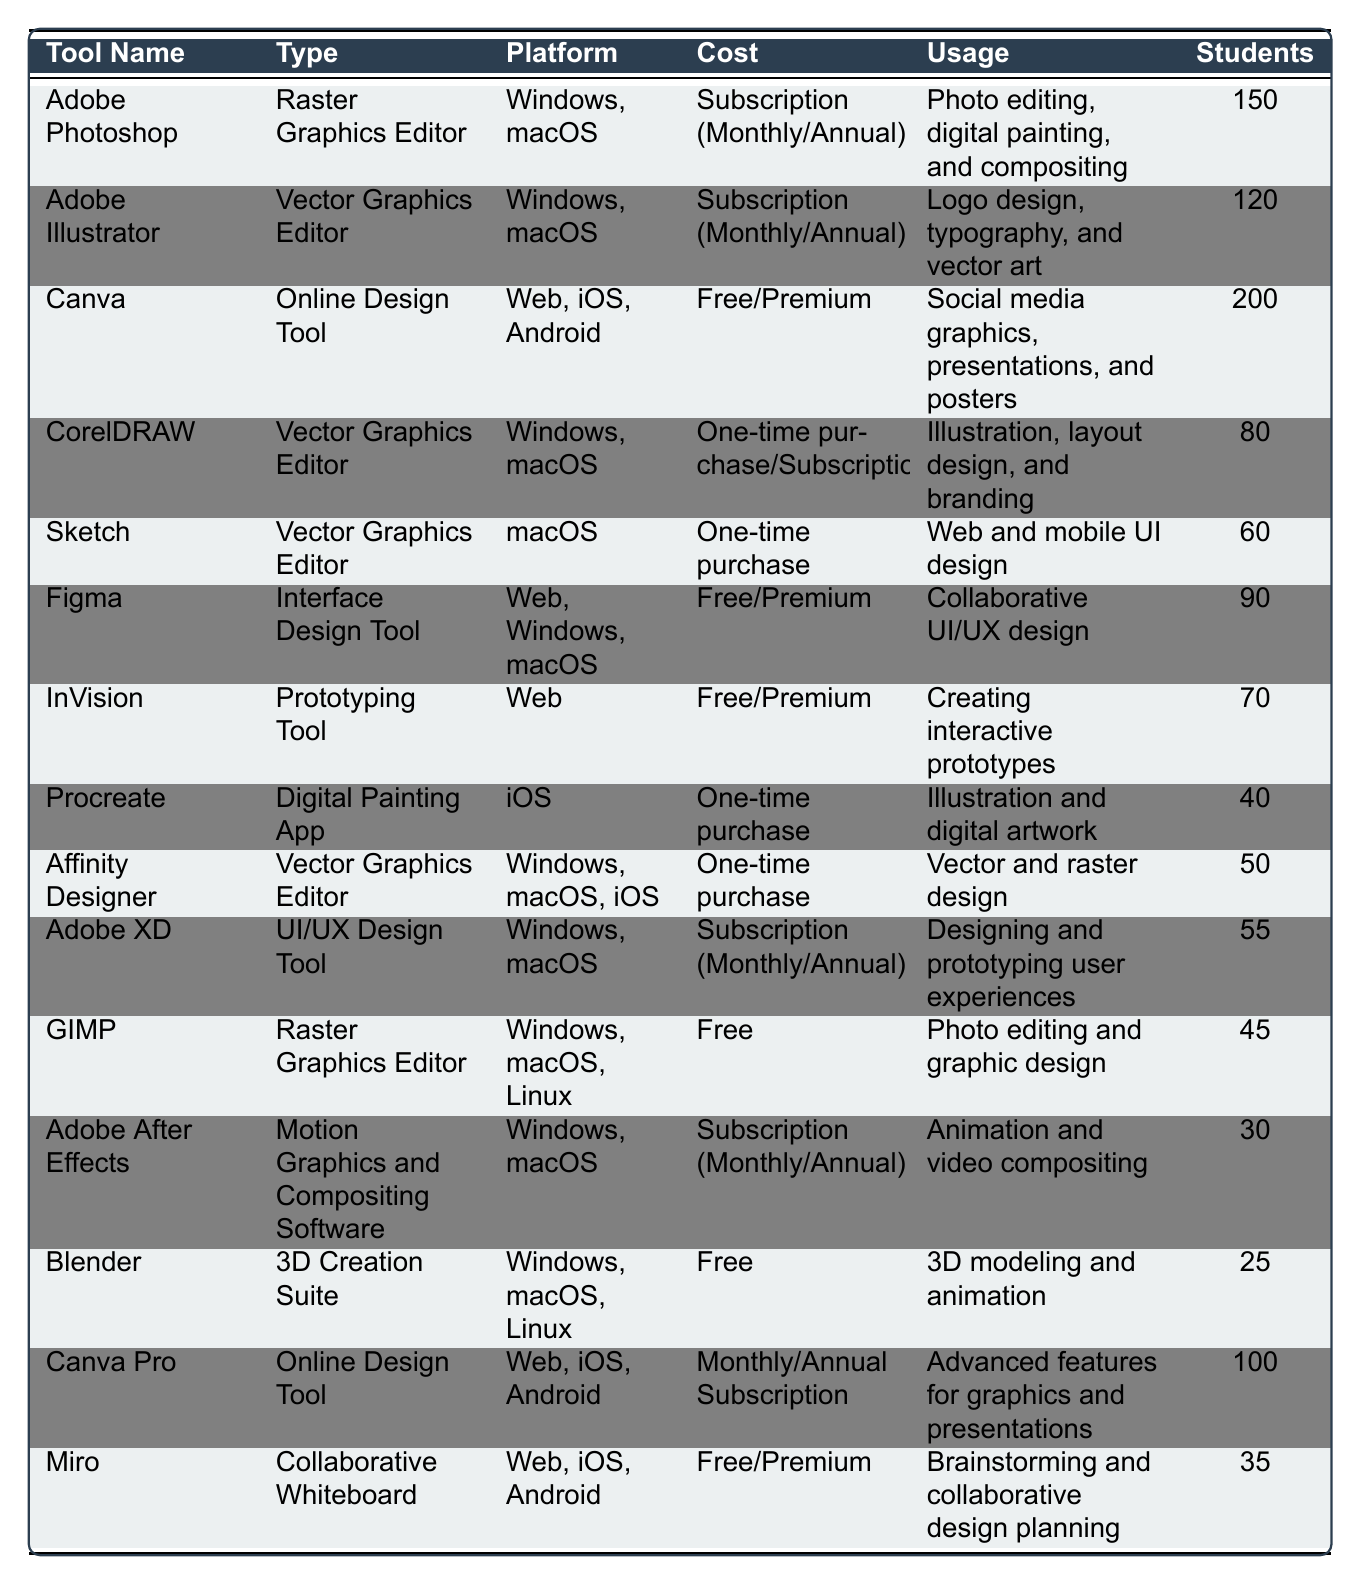What is the most popular design tool among graphic design majors? By looking at the 'Students' column, we can see that Canva has the highest count with 200 students using it, which is more than any other tool listed.
Answer: Canva How many students are using Adobe Photoshop? The table indicates that 150 students are using Adobe Photoshop, as shown in the 'Students' column next to its entry.
Answer: 150 Which tools have more than 100 students? To find this, we inspect the 'Students' column and identify that Canva (200), Adobe Photoshop (150), Adobe Illustrator (120), and Canva Pro (100) have more than 100 students.
Answer: Canva, Adobe Photoshop, Adobe Illustrator, Canva Pro What is the total number of students using all tools listed? We sum up the students count from all tools: 150 + 120 + 200 + 80 + 60 + 90 + 70 + 40 + 50 + 55 + 45 + 30 + 25 + 100 + 35 = 1,200. By adding these numbers, we find that the total number of students is 1,200.
Answer: 1200 Which tool type is used by the most students, and how many are using it? The most used tool type is "Online Design Tool," which includes Canva with 200 students and Canva Pro with 100 students. The total for this type is thus 200 + 100 = 300 students.
Answer: Online Design Tool, 300 Is GIMP a more popular tool than Procreate among students? GIMP has 45 students, while Procreate has 40. Comparing these two numbers, GIMP is more popular as it has more students using it.
Answer: Yes What is the average number of students using the Vector Graphics Editor tools? The Vector Graphics Editors are Adobe Illustrator (120), CorelDRAW (80), Sketch (60), and Affinity Designer (50). The total is 120 + 80 + 60 + 50 = 310, and the average is 310/4 = 77.5.
Answer: 77.5 Which platform has the most design tools listed? The platforms listed include Windows, macOS, Web, and iOS. By counting: Windows (6 tools), macOS (6 tools), Web (6 tools), and iOS (4 tools), we see that Windows, macOS, and Web all have the same highest count of 6 tools.
Answer: Windows, macOS, Web How many tools are available for free? The tools listed as free are Canva, GIMP, Blender, and the free version of Miro, which totals 4 tools.
Answer: 4 What percentage of students use Adobe After Effects relative to the total number of students? Adobe After Effects has 30 students. Since the total is 1,200, the percentage is (30/1200) * 100 = 2.5%.
Answer: 2.5% 